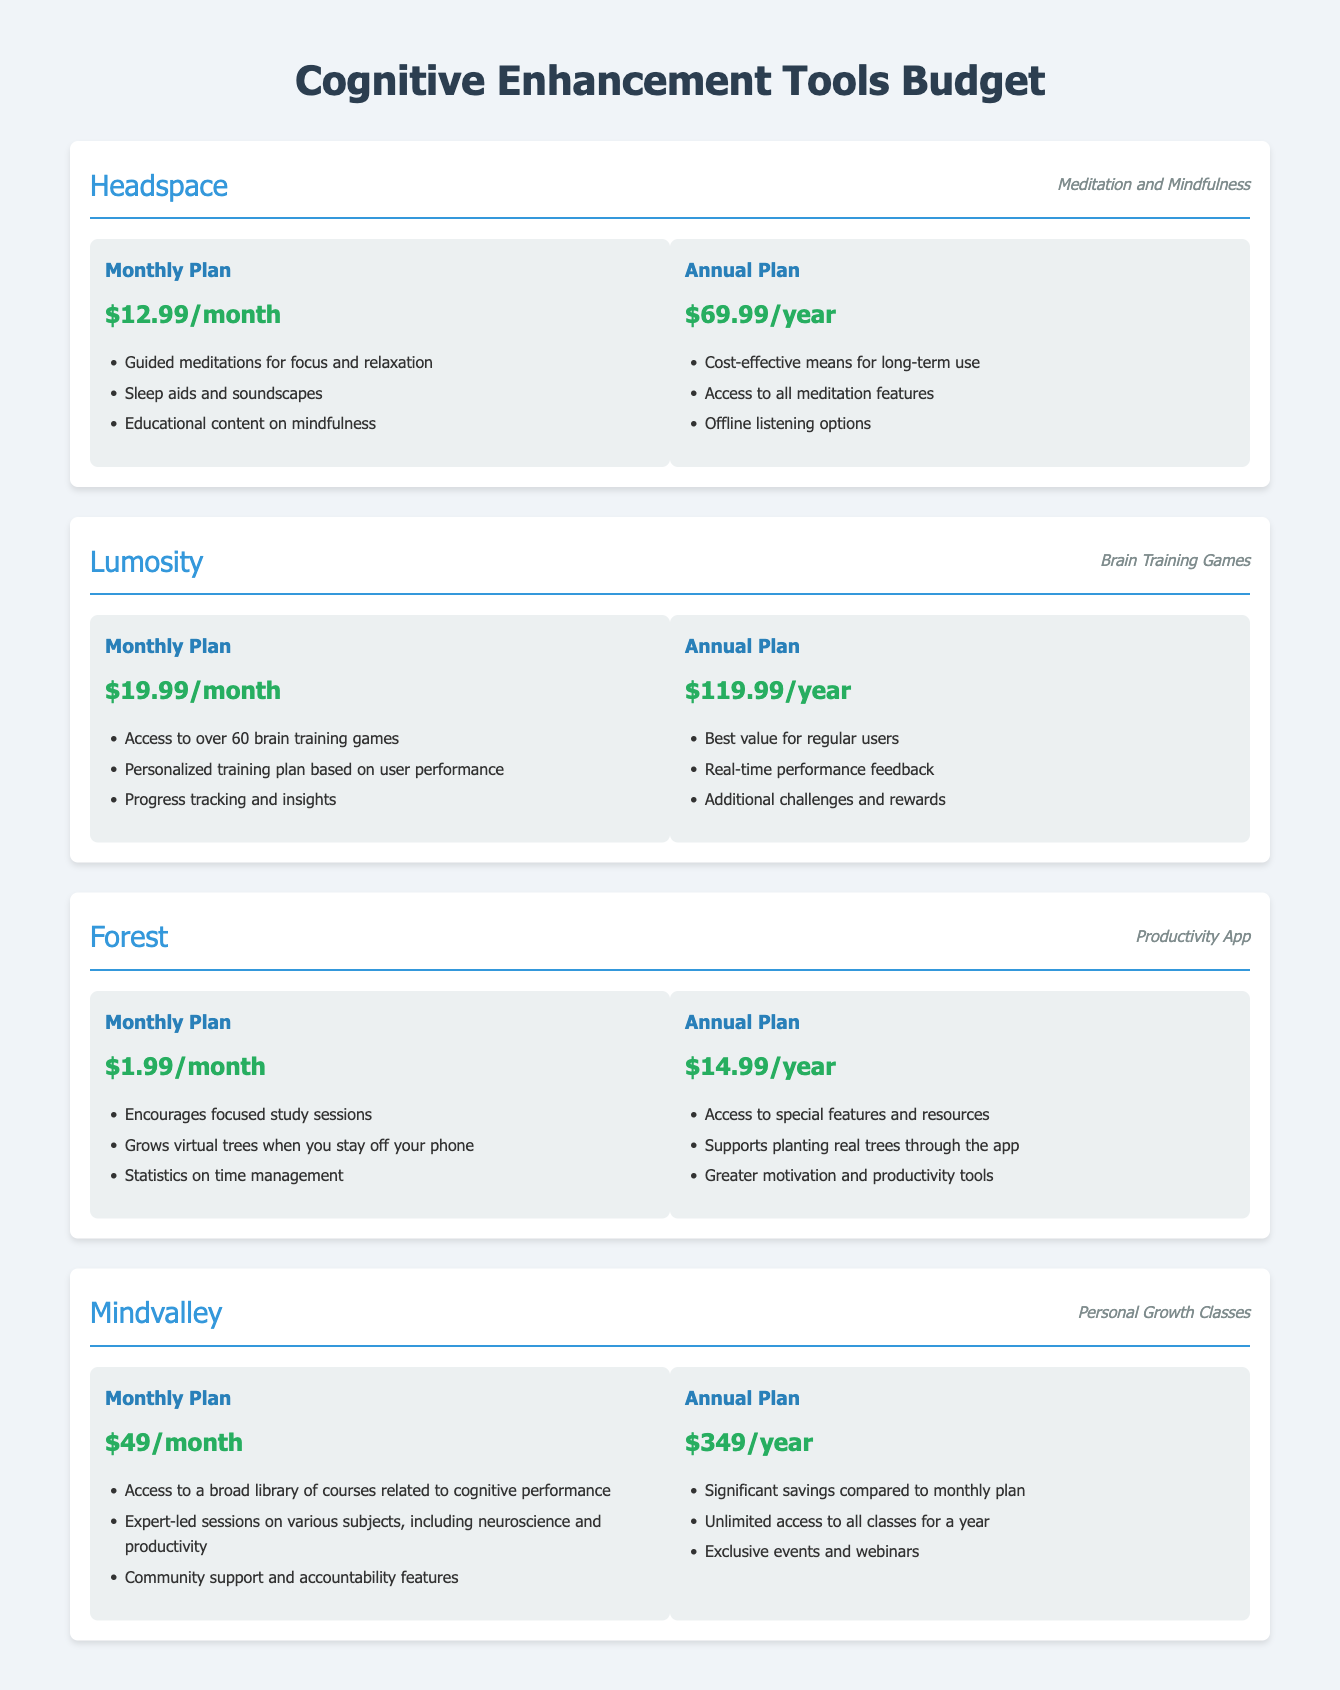What is the cost of the Headspace Annual Plan? The annual plan for Headspace costs $69.99 per year.
Answer: $69.99/year How many brain training games does Lumosity offer? Lumosity provides access to over 60 brain training games.
Answer: over 60 What is the monthly cost of the Forest app? The monthly plan for Forest costs $1.99 per month.
Answer: $1.99/month What type of content does Mindvalley provide? Mindvalley offers personal growth classes related to cognitive performance.
Answer: Personal growth classes What is the total annual cost for subscribing to all tools using their annual plans? The total annual cost is calculated as $69.99 + $119.99 + $14.99 + $349 = $554.97.
Answer: $554.97 How does the Forest app assist with productivity? The Forest app encourages focused study sessions by growing virtual trees when you stay off your phone.
Answer: Grows virtual trees What is the price difference between monthly and annual plans for Lumosity? The monthly plan is $19.99, while the annual plan is $119.99, leading to a price difference of $100.00.
Answer: $100.00 Which tool includes educational content on mindfulness? The tool that includes educational content on mindfulness is Headspace.
Answer: Headspace What additional benefit comes with the annual plan of the Forest app? The annual plan offers access to special features and supports planting real trees.
Answer: Planting real trees 